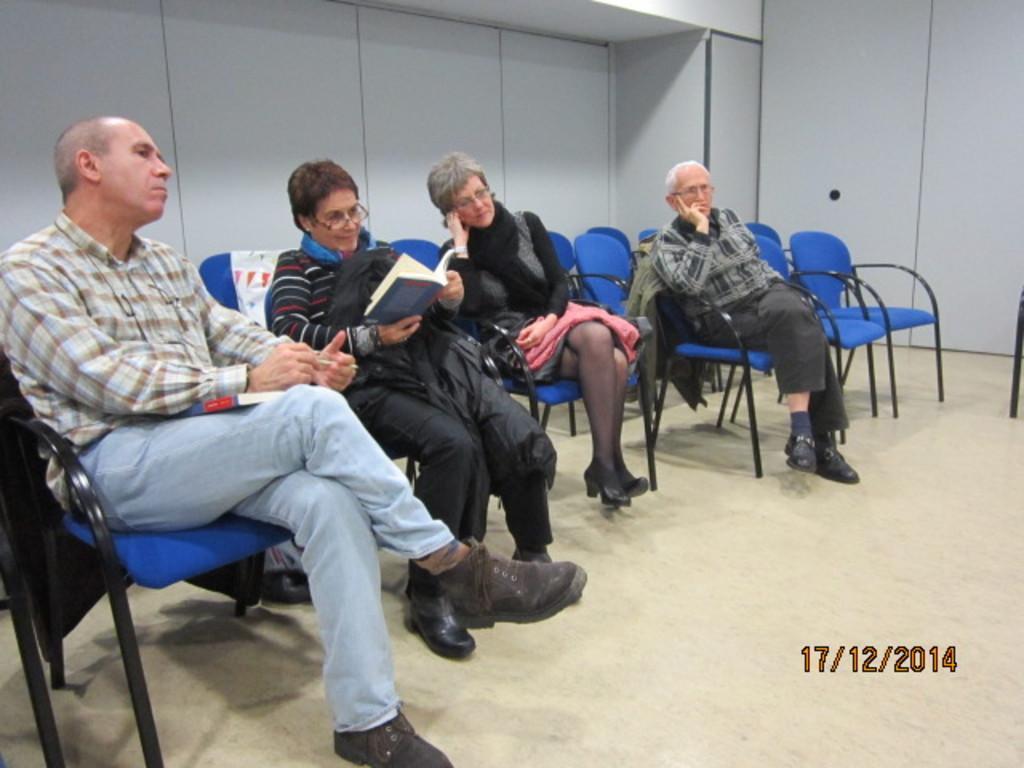Please provide a concise description of this image. This image is taken inside a room. There are four people in this image. In the right side of the image there are few empty chairs and a cupboard. In the left side of the image there is a man sitting on a chair. At the bottom of the image there is a floor with mat. At the background there is a wall. In the middle of the image two women are sitting on the chairs. 